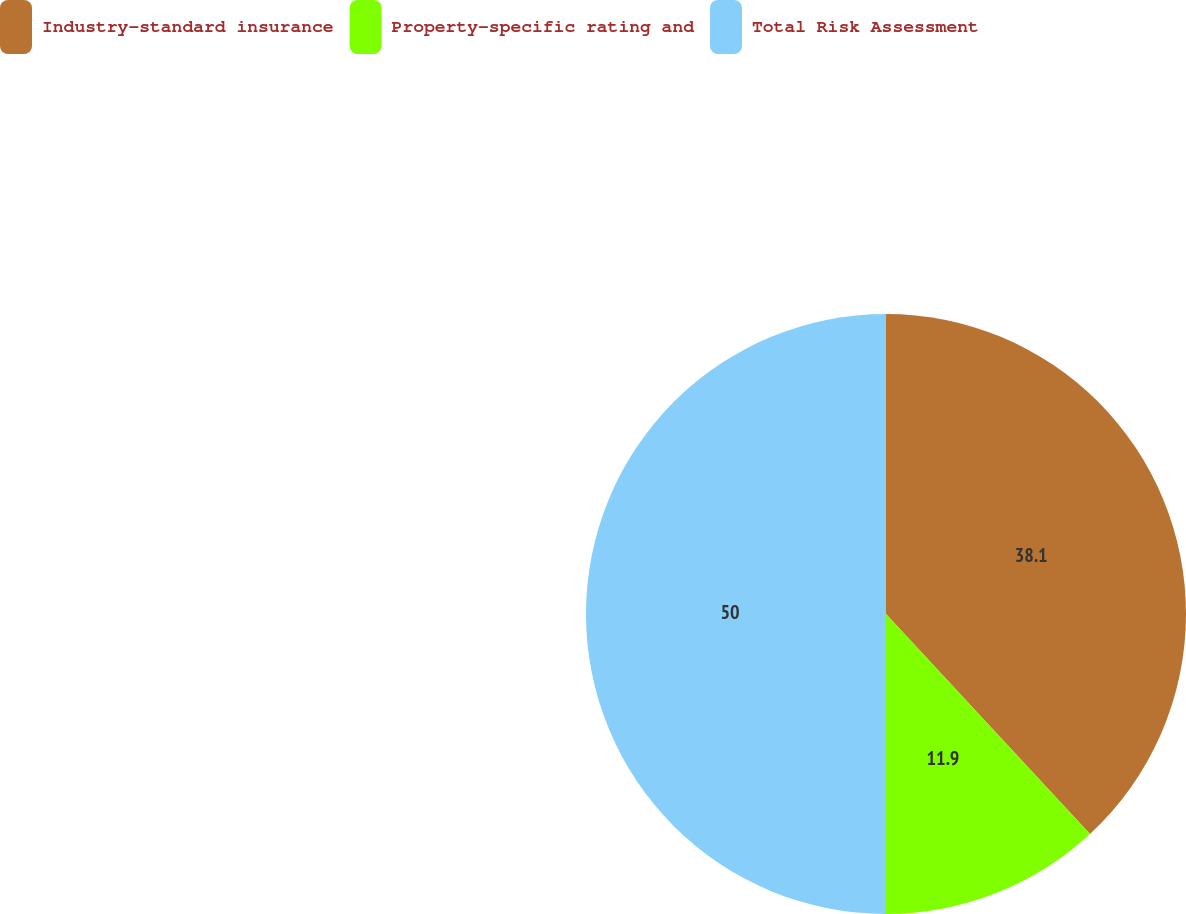Convert chart to OTSL. <chart><loc_0><loc_0><loc_500><loc_500><pie_chart><fcel>Industry-standard insurance<fcel>Property-specific rating and<fcel>Total Risk Assessment<nl><fcel>38.1%<fcel>11.9%<fcel>50.0%<nl></chart> 